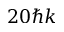<formula> <loc_0><loc_0><loc_500><loc_500>2 0 \hbar { k }</formula> 